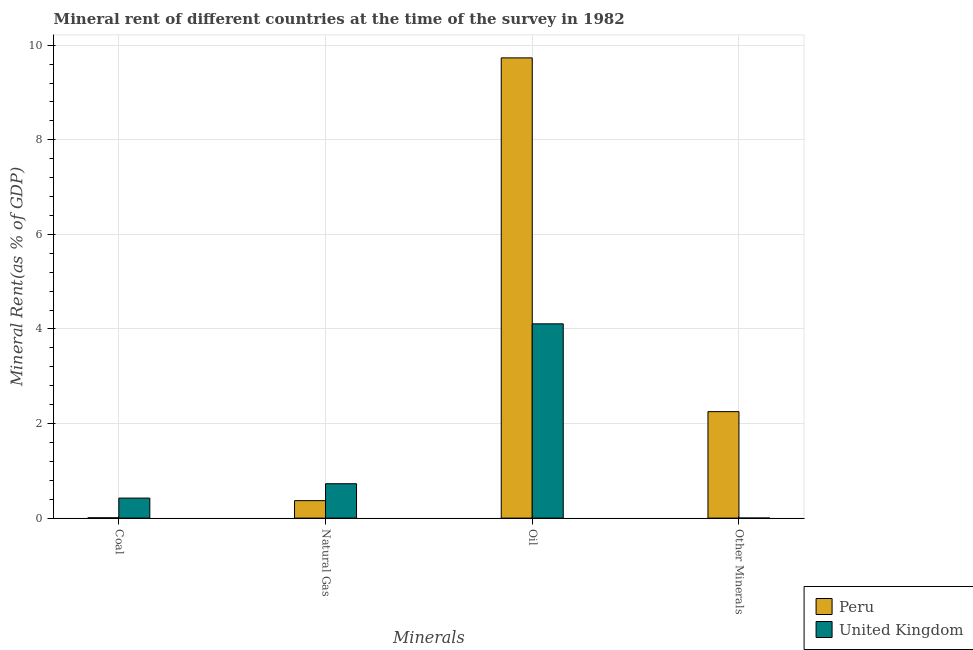How many different coloured bars are there?
Give a very brief answer. 2. How many groups of bars are there?
Offer a terse response. 4. Are the number of bars on each tick of the X-axis equal?
Your answer should be compact. Yes. How many bars are there on the 3rd tick from the left?
Provide a short and direct response. 2. What is the label of the 3rd group of bars from the left?
Your response must be concise. Oil. What is the  rent of other minerals in Peru?
Offer a terse response. 2.25. Across all countries, what is the maximum  rent of other minerals?
Your answer should be very brief. 2.25. Across all countries, what is the minimum  rent of other minerals?
Provide a short and direct response. 0. What is the total natural gas rent in the graph?
Provide a short and direct response. 1.1. What is the difference between the natural gas rent in United Kingdom and that in Peru?
Give a very brief answer. 0.36. What is the difference between the oil rent in Peru and the  rent of other minerals in United Kingdom?
Offer a very short reply. 9.73. What is the average coal rent per country?
Your answer should be compact. 0.22. What is the difference between the oil rent and  rent of other minerals in United Kingdom?
Give a very brief answer. 4.11. What is the ratio of the oil rent in Peru to that in United Kingdom?
Ensure brevity in your answer.  2.37. What is the difference between the highest and the second highest  rent of other minerals?
Offer a terse response. 2.25. What is the difference between the highest and the lowest coal rent?
Provide a short and direct response. 0.42. What does the 1st bar from the left in Natural Gas represents?
Your answer should be compact. Peru. Are all the bars in the graph horizontal?
Your answer should be very brief. No. How many countries are there in the graph?
Your response must be concise. 2. What is the difference between two consecutive major ticks on the Y-axis?
Make the answer very short. 2. Does the graph contain grids?
Make the answer very short. Yes. Where does the legend appear in the graph?
Offer a very short reply. Bottom right. How many legend labels are there?
Make the answer very short. 2. How are the legend labels stacked?
Keep it short and to the point. Vertical. What is the title of the graph?
Offer a very short reply. Mineral rent of different countries at the time of the survey in 1982. What is the label or title of the X-axis?
Your answer should be compact. Minerals. What is the label or title of the Y-axis?
Offer a very short reply. Mineral Rent(as % of GDP). What is the Mineral Rent(as % of GDP) in Peru in Coal?
Your response must be concise. 0.01. What is the Mineral Rent(as % of GDP) in United Kingdom in Coal?
Make the answer very short. 0.42. What is the Mineral Rent(as % of GDP) in Peru in Natural Gas?
Provide a succinct answer. 0.37. What is the Mineral Rent(as % of GDP) of United Kingdom in Natural Gas?
Your response must be concise. 0.73. What is the Mineral Rent(as % of GDP) of Peru in Oil?
Your response must be concise. 9.73. What is the Mineral Rent(as % of GDP) in United Kingdom in Oil?
Give a very brief answer. 4.11. What is the Mineral Rent(as % of GDP) of Peru in Other Minerals?
Keep it short and to the point. 2.25. What is the Mineral Rent(as % of GDP) in United Kingdom in Other Minerals?
Make the answer very short. 0. Across all Minerals, what is the maximum Mineral Rent(as % of GDP) in Peru?
Make the answer very short. 9.73. Across all Minerals, what is the maximum Mineral Rent(as % of GDP) in United Kingdom?
Offer a very short reply. 4.11. Across all Minerals, what is the minimum Mineral Rent(as % of GDP) of Peru?
Offer a very short reply. 0.01. Across all Minerals, what is the minimum Mineral Rent(as % of GDP) of United Kingdom?
Your response must be concise. 0. What is the total Mineral Rent(as % of GDP) in Peru in the graph?
Your answer should be very brief. 12.36. What is the total Mineral Rent(as % of GDP) in United Kingdom in the graph?
Your answer should be very brief. 5.26. What is the difference between the Mineral Rent(as % of GDP) in Peru in Coal and that in Natural Gas?
Your answer should be compact. -0.36. What is the difference between the Mineral Rent(as % of GDP) of United Kingdom in Coal and that in Natural Gas?
Keep it short and to the point. -0.3. What is the difference between the Mineral Rent(as % of GDP) of Peru in Coal and that in Oil?
Keep it short and to the point. -9.73. What is the difference between the Mineral Rent(as % of GDP) of United Kingdom in Coal and that in Oil?
Offer a terse response. -3.68. What is the difference between the Mineral Rent(as % of GDP) of Peru in Coal and that in Other Minerals?
Your response must be concise. -2.24. What is the difference between the Mineral Rent(as % of GDP) in United Kingdom in Coal and that in Other Minerals?
Provide a short and direct response. 0.42. What is the difference between the Mineral Rent(as % of GDP) in Peru in Natural Gas and that in Oil?
Your response must be concise. -9.36. What is the difference between the Mineral Rent(as % of GDP) in United Kingdom in Natural Gas and that in Oil?
Offer a terse response. -3.38. What is the difference between the Mineral Rent(as % of GDP) in Peru in Natural Gas and that in Other Minerals?
Provide a succinct answer. -1.88. What is the difference between the Mineral Rent(as % of GDP) of United Kingdom in Natural Gas and that in Other Minerals?
Provide a short and direct response. 0.73. What is the difference between the Mineral Rent(as % of GDP) of Peru in Oil and that in Other Minerals?
Offer a terse response. 7.48. What is the difference between the Mineral Rent(as % of GDP) of United Kingdom in Oil and that in Other Minerals?
Provide a succinct answer. 4.11. What is the difference between the Mineral Rent(as % of GDP) of Peru in Coal and the Mineral Rent(as % of GDP) of United Kingdom in Natural Gas?
Make the answer very short. -0.72. What is the difference between the Mineral Rent(as % of GDP) of Peru in Coal and the Mineral Rent(as % of GDP) of United Kingdom in Oil?
Make the answer very short. -4.1. What is the difference between the Mineral Rent(as % of GDP) in Peru in Coal and the Mineral Rent(as % of GDP) in United Kingdom in Other Minerals?
Give a very brief answer. 0.01. What is the difference between the Mineral Rent(as % of GDP) in Peru in Natural Gas and the Mineral Rent(as % of GDP) in United Kingdom in Oil?
Your response must be concise. -3.74. What is the difference between the Mineral Rent(as % of GDP) of Peru in Natural Gas and the Mineral Rent(as % of GDP) of United Kingdom in Other Minerals?
Provide a succinct answer. 0.37. What is the difference between the Mineral Rent(as % of GDP) of Peru in Oil and the Mineral Rent(as % of GDP) of United Kingdom in Other Minerals?
Provide a succinct answer. 9.73. What is the average Mineral Rent(as % of GDP) of Peru per Minerals?
Your answer should be compact. 3.09. What is the average Mineral Rent(as % of GDP) of United Kingdom per Minerals?
Give a very brief answer. 1.32. What is the difference between the Mineral Rent(as % of GDP) in Peru and Mineral Rent(as % of GDP) in United Kingdom in Coal?
Make the answer very short. -0.42. What is the difference between the Mineral Rent(as % of GDP) of Peru and Mineral Rent(as % of GDP) of United Kingdom in Natural Gas?
Provide a succinct answer. -0.36. What is the difference between the Mineral Rent(as % of GDP) in Peru and Mineral Rent(as % of GDP) in United Kingdom in Oil?
Offer a terse response. 5.62. What is the difference between the Mineral Rent(as % of GDP) in Peru and Mineral Rent(as % of GDP) in United Kingdom in Other Minerals?
Your answer should be very brief. 2.25. What is the ratio of the Mineral Rent(as % of GDP) of Peru in Coal to that in Natural Gas?
Provide a short and direct response. 0.02. What is the ratio of the Mineral Rent(as % of GDP) in United Kingdom in Coal to that in Natural Gas?
Ensure brevity in your answer.  0.58. What is the ratio of the Mineral Rent(as % of GDP) of Peru in Coal to that in Oil?
Keep it short and to the point. 0. What is the ratio of the Mineral Rent(as % of GDP) of United Kingdom in Coal to that in Oil?
Provide a short and direct response. 0.1. What is the ratio of the Mineral Rent(as % of GDP) of Peru in Coal to that in Other Minerals?
Offer a very short reply. 0. What is the ratio of the Mineral Rent(as % of GDP) of United Kingdom in Coal to that in Other Minerals?
Provide a succinct answer. 243.05. What is the ratio of the Mineral Rent(as % of GDP) in Peru in Natural Gas to that in Oil?
Your answer should be very brief. 0.04. What is the ratio of the Mineral Rent(as % of GDP) in United Kingdom in Natural Gas to that in Oil?
Give a very brief answer. 0.18. What is the ratio of the Mineral Rent(as % of GDP) in Peru in Natural Gas to that in Other Minerals?
Your answer should be very brief. 0.16. What is the ratio of the Mineral Rent(as % of GDP) of United Kingdom in Natural Gas to that in Other Minerals?
Make the answer very short. 417.35. What is the ratio of the Mineral Rent(as % of GDP) in Peru in Oil to that in Other Minerals?
Your response must be concise. 4.32. What is the ratio of the Mineral Rent(as % of GDP) in United Kingdom in Oil to that in Other Minerals?
Your answer should be very brief. 2357.47. What is the difference between the highest and the second highest Mineral Rent(as % of GDP) in Peru?
Provide a short and direct response. 7.48. What is the difference between the highest and the second highest Mineral Rent(as % of GDP) in United Kingdom?
Your answer should be compact. 3.38. What is the difference between the highest and the lowest Mineral Rent(as % of GDP) in Peru?
Give a very brief answer. 9.73. What is the difference between the highest and the lowest Mineral Rent(as % of GDP) in United Kingdom?
Offer a very short reply. 4.11. 